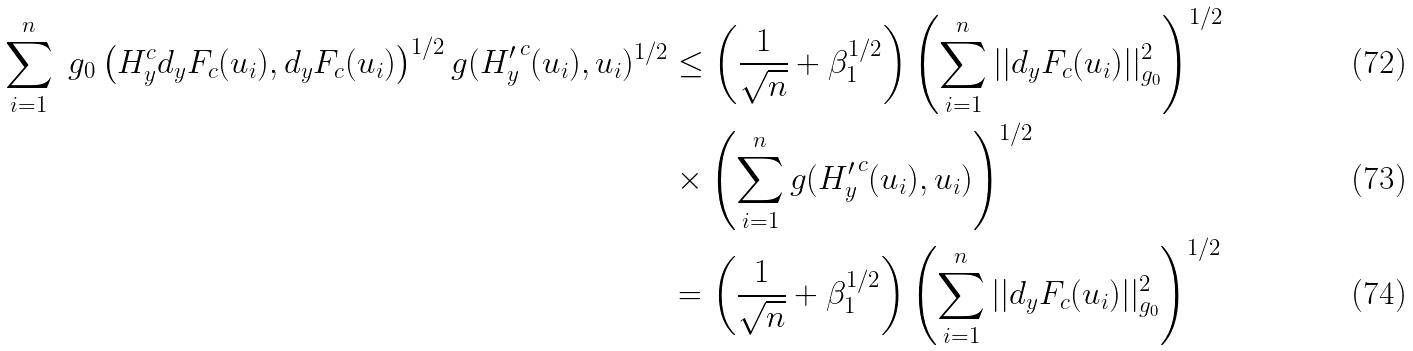Convert formula to latex. <formula><loc_0><loc_0><loc_500><loc_500>\sum _ { i = 1 } ^ { n } \ g _ { 0 } \left ( H _ { y } ^ { c } d _ { y } F _ { c } ( u _ { i } ) , d _ { y } F _ { c } ( u _ { i } ) \right ) ^ { 1 / 2 } g ( { H ^ { \prime } _ { y } } ^ { c } ( u _ { i } ) , u _ { i } ) ^ { 1 / 2 } & \leq \left ( \frac { 1 } { \sqrt { n } } + \beta _ { 1 } ^ { 1 / 2 } \right ) \left ( \sum _ { i = 1 } ^ { n } | | d _ { y } F _ { c } ( u _ { i } ) | | _ { g _ { 0 } } ^ { 2 } \right ) ^ { 1 / 2 } \\ & \times \left ( \sum _ { i = 1 } ^ { n } g ( { H ^ { \prime } _ { y } } ^ { c } ( u _ { i } ) , u _ { i } ) \right ) ^ { 1 / 2 } \\ & = \left ( \frac { 1 } { \sqrt { n } } + \beta _ { 1 } ^ { 1 / 2 } \right ) \left ( \sum _ { i = 1 } ^ { n } | | d _ { y } F _ { c } ( u _ { i } ) | | _ { g _ { 0 } } ^ { 2 } \right ) ^ { 1 / 2 }</formula> 